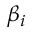<formula> <loc_0><loc_0><loc_500><loc_500>\beta _ { i }</formula> 